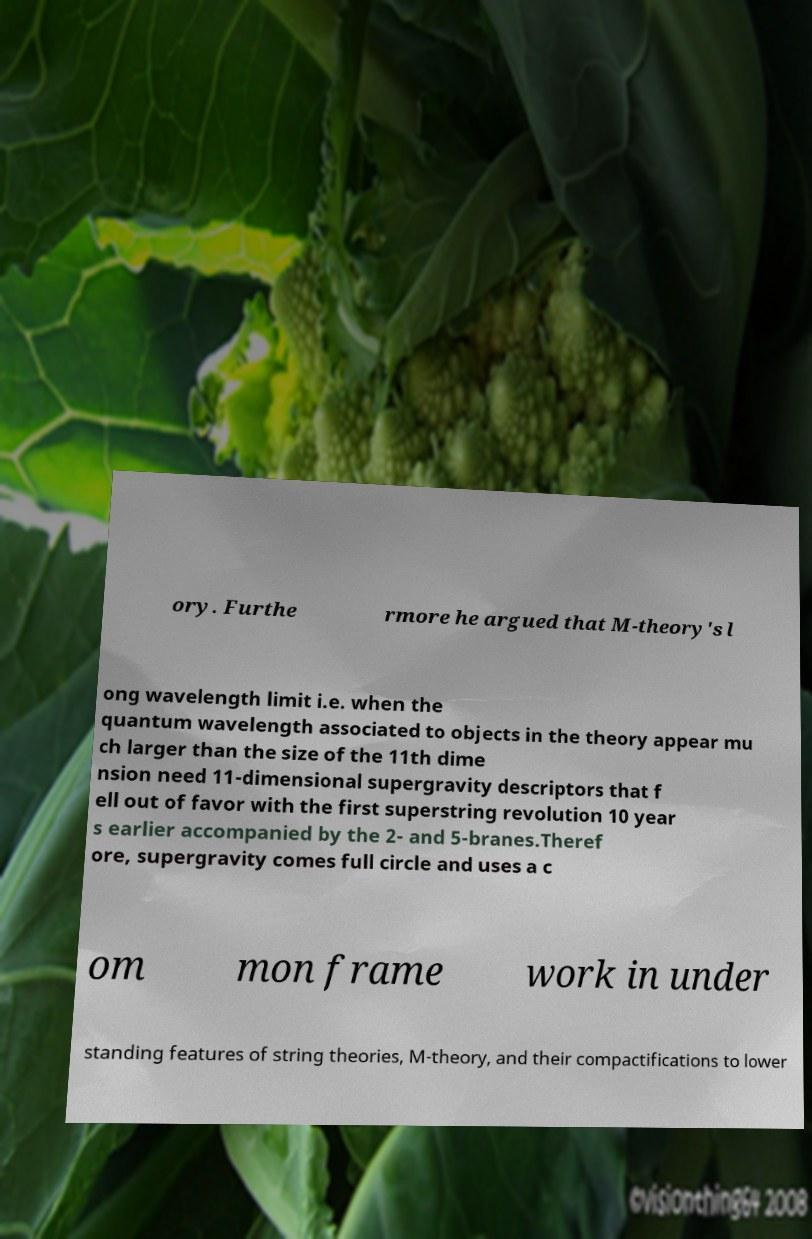Please read and relay the text visible in this image. What does it say? ory. Furthe rmore he argued that M-theory's l ong wavelength limit i.e. when the quantum wavelength associated to objects in the theory appear mu ch larger than the size of the 11th dime nsion need 11-dimensional supergravity descriptors that f ell out of favor with the first superstring revolution 10 year s earlier accompanied by the 2- and 5-branes.Theref ore, supergravity comes full circle and uses a c om mon frame work in under standing features of string theories, M-theory, and their compactifications to lower 